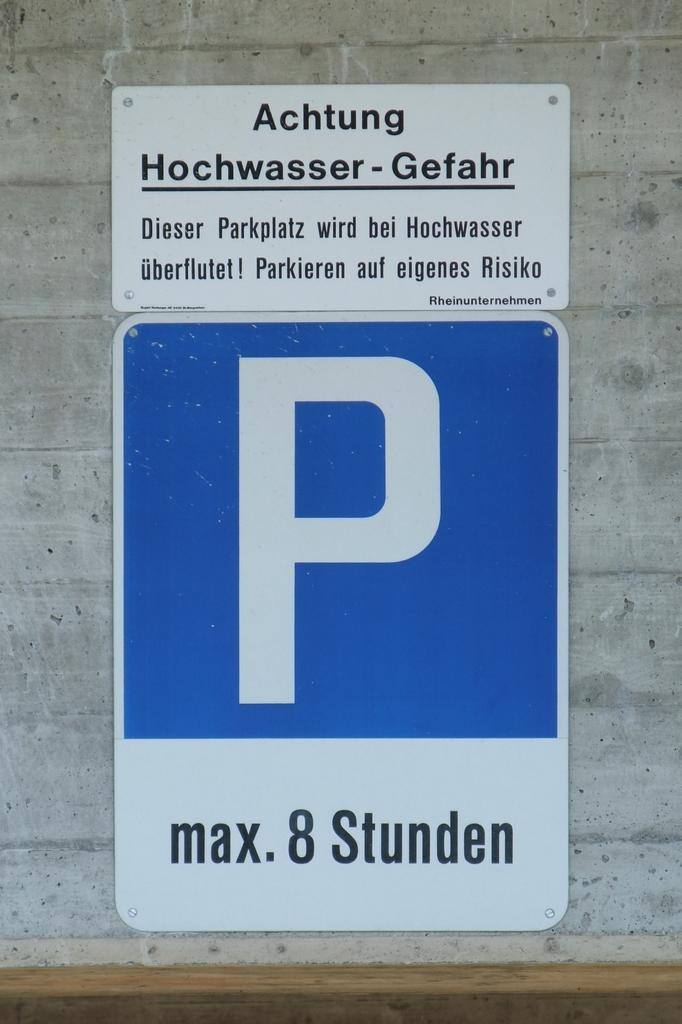Where was the image taken? The image was clicked outside. What can be seen in the center of the image? There are posts attached to a wall in the center of the image. What is written on the posters? There is text on the posters. What is located in the foreground of the image? There is a wooden object in the foreground of the image. What type of thunder can be heard in the background of the image? There is no sound present in the image, so it is not possible to determine if any thunder can be heard. 